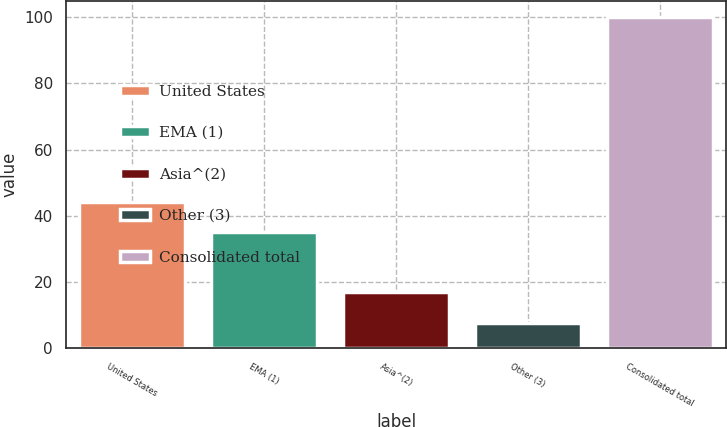<chart> <loc_0><loc_0><loc_500><loc_500><bar_chart><fcel>United States<fcel>EMA (1)<fcel>Asia^(2)<fcel>Other (3)<fcel>Consolidated total<nl><fcel>44.32<fcel>35.1<fcel>17.02<fcel>7.8<fcel>100<nl></chart> 